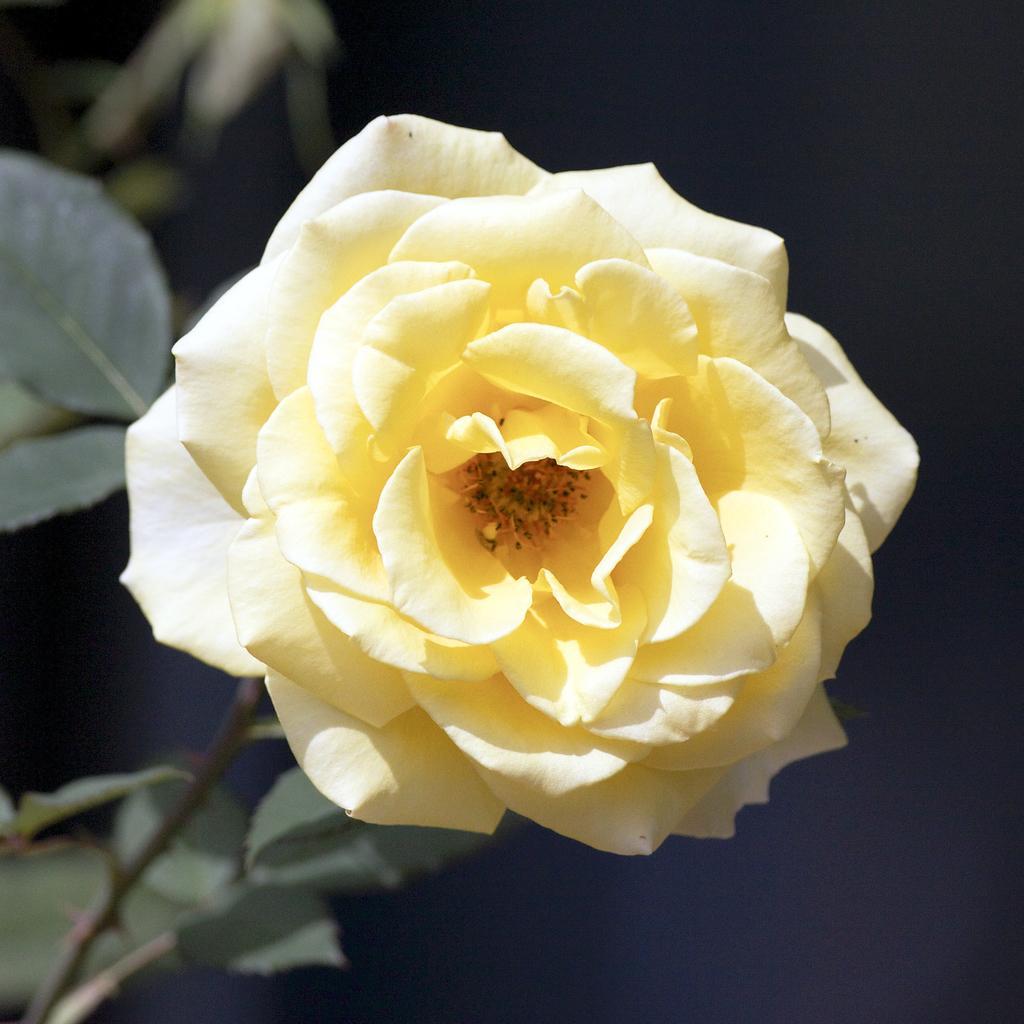How would you summarize this image in a sentence or two? In this picture I can see there is a yellow color rose and it has leaves and the flower is attached to the stem. The backdrop is dark. 